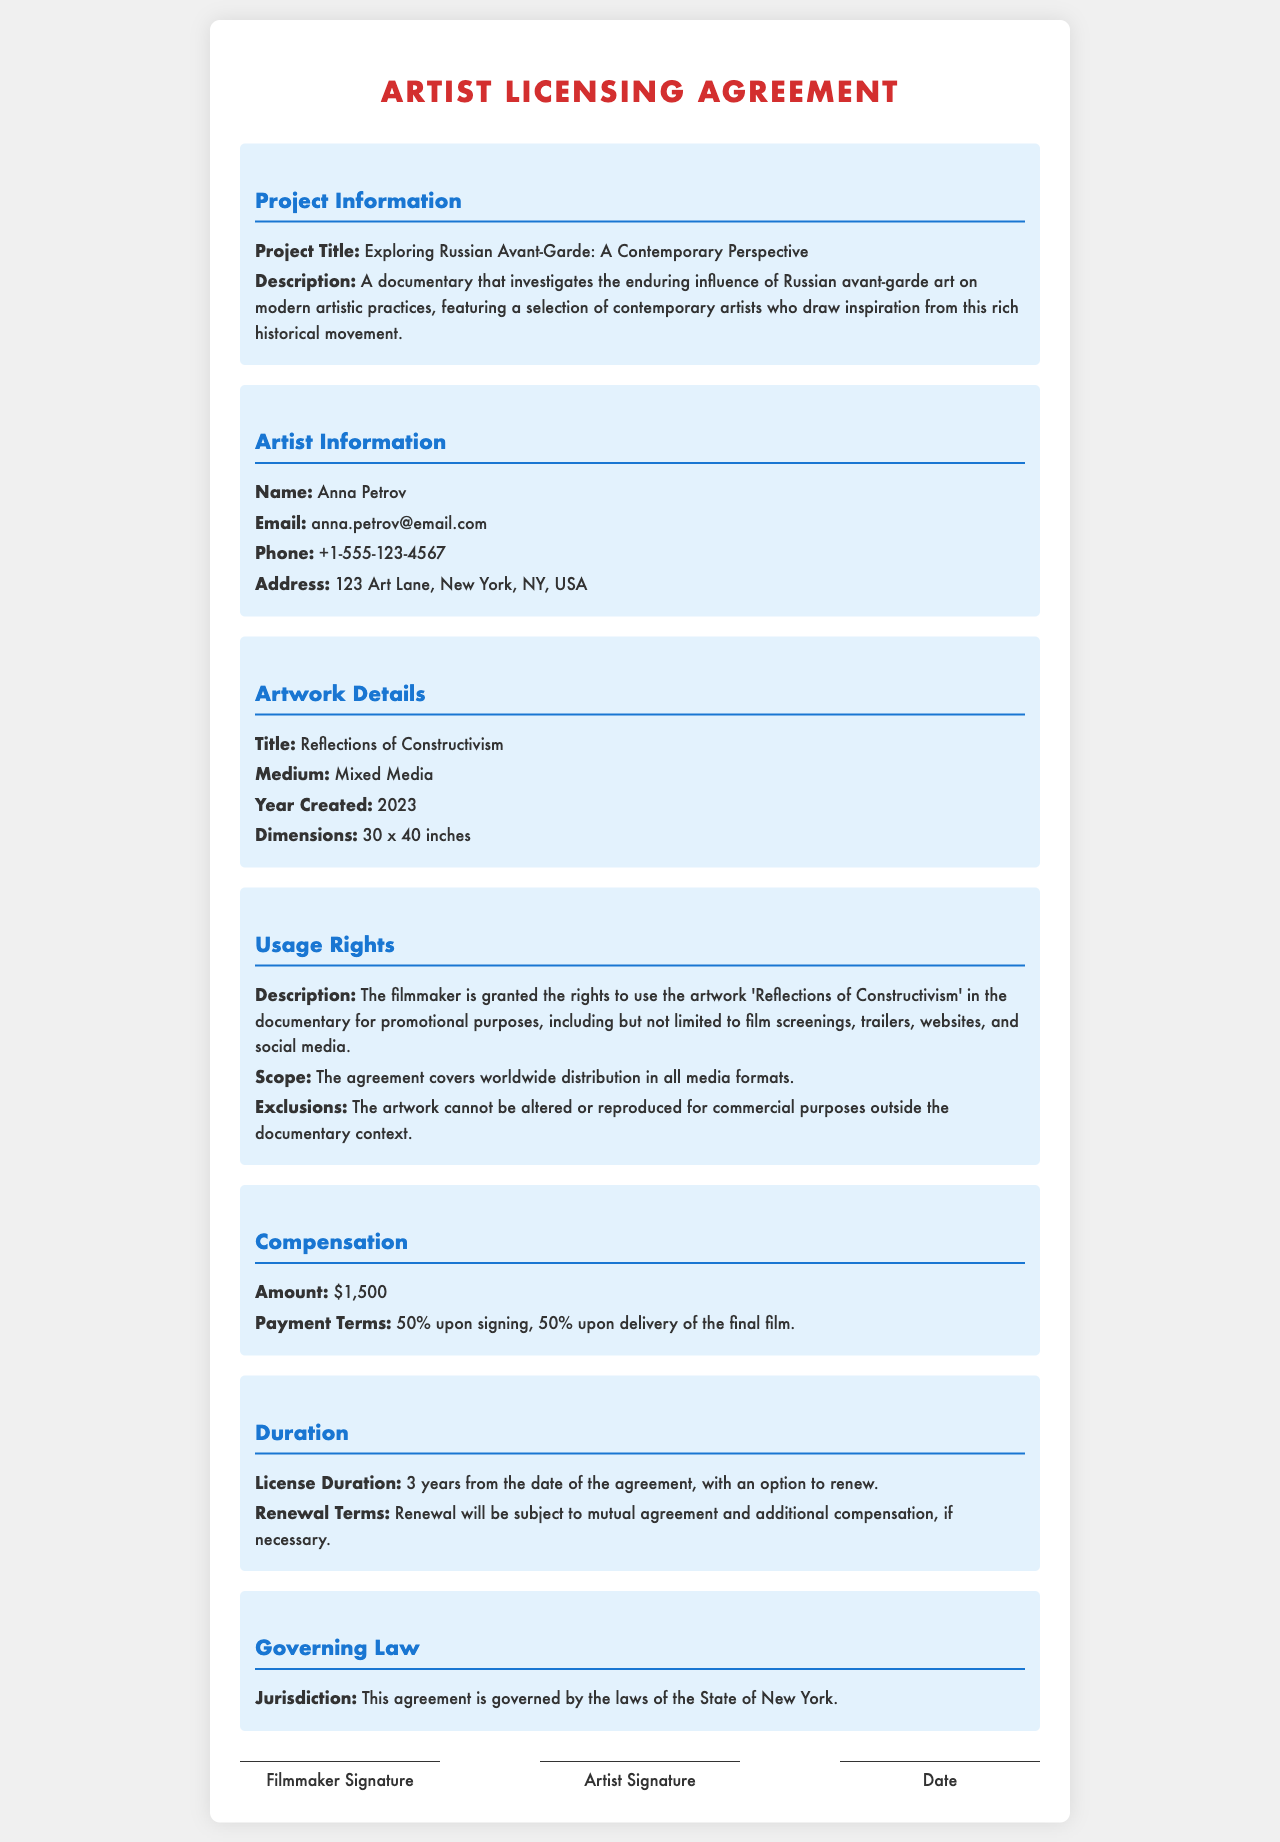what is the project title? The project title is provided in the "Project Information" section of the document.
Answer: Exploring Russian Avant-Garde: A Contemporary Perspective who is the artist? The artist's name is specified in the "Artist Information" section of the document.
Answer: Anna Petrov what is the compensation amount? The compensation amount is clearly stated in the "Compensation" section of the document.
Answer: $1,500 how long is the license duration? The duration of the license is mentioned in the "Duration" section of the document.
Answer: 3 years what are the payment terms? The payment terms are listed in the "Compensation" section of the document and include breakdowns upon signing and delivery.
Answer: 50% upon signing, 50% upon delivery of the final film what rights does the filmmaker obtain for the artwork? The rights granted to the filmmaker are detailed in the "Usage Rights" section of the document.
Answer: Use for promotional purposes which jurisdiction governs the agreement? The governing law is indicated in the "Governing Law" section of the document.
Answer: State of New York what type of artwork is being licensed? The type of artwork is described in the "Artwork Details" section of the document.
Answer: Mixed Media what is the title of the artwork? The title of the artwork is explicitly stated in the "Artwork Details" section of the document.
Answer: Reflections of Constructivism 